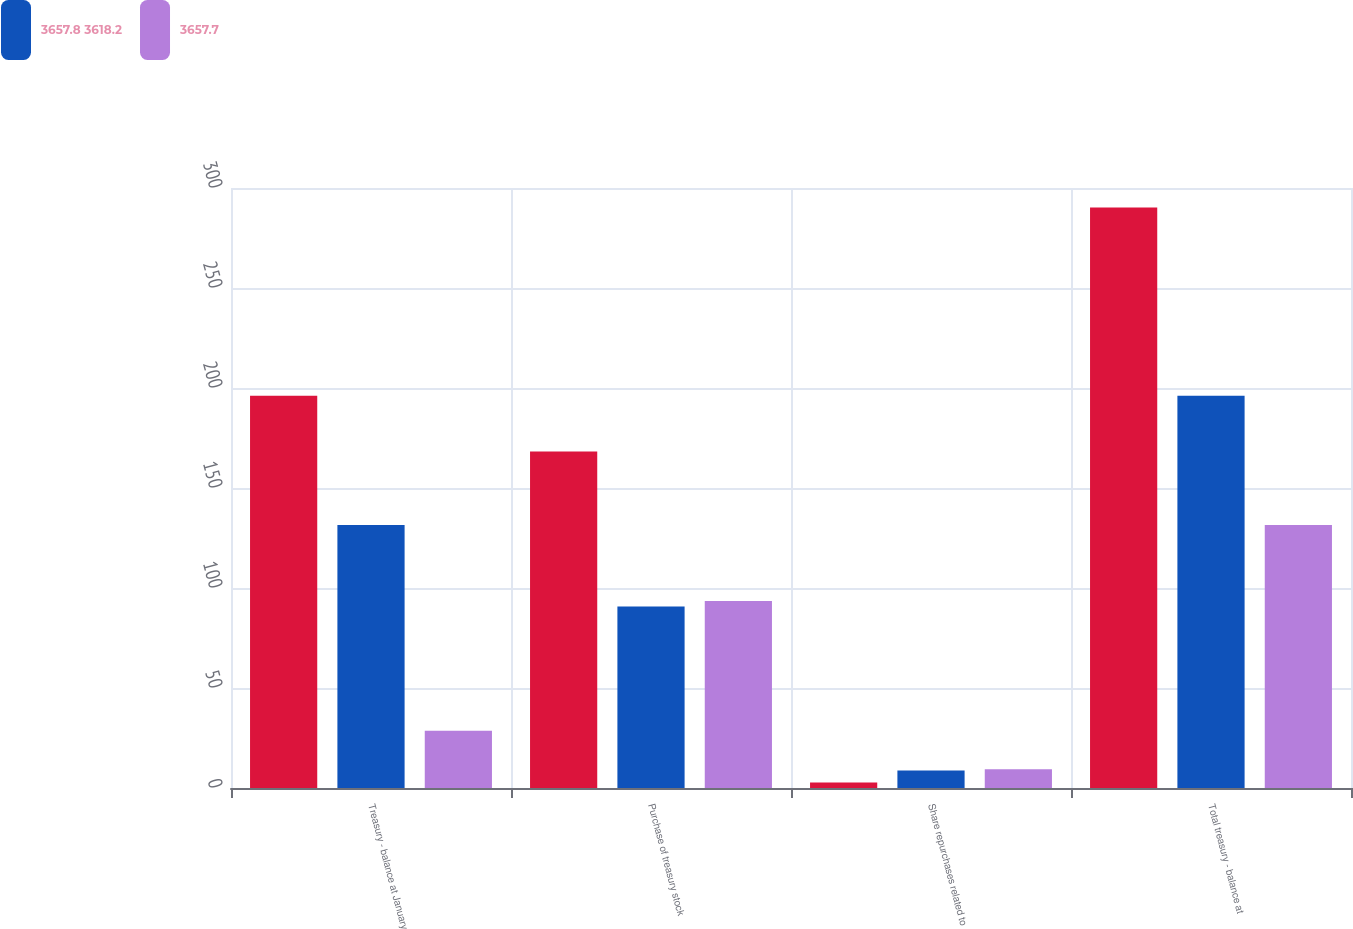Convert chart to OTSL. <chart><loc_0><loc_0><loc_500><loc_500><stacked_bar_chart><ecel><fcel>Treasury - balance at January<fcel>Purchase of treasury stock<fcel>Share repurchases related to<fcel>Total treasury - balance at<nl><fcel>nan<fcel>196.1<fcel>168.2<fcel>2.7<fcel>290.3<nl><fcel>3657.8 3618.2<fcel>131.5<fcel>90.7<fcel>8.8<fcel>196.1<nl><fcel>3657.7<fcel>28.6<fcel>93.5<fcel>9.4<fcel>131.5<nl></chart> 